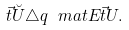Convert formula to latex. <formula><loc_0><loc_0><loc_500><loc_500>\vec { t } { \breve { U } } \triangle q \ m a t { E } \vec { t } { U } .</formula> 